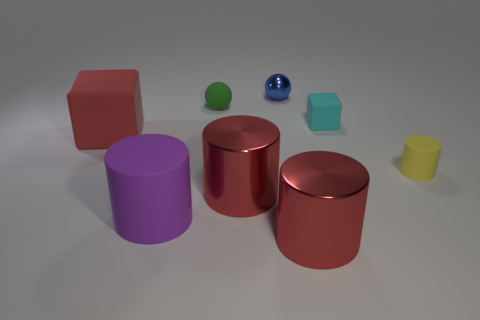How many red objects are either large rubber things or metal balls?
Keep it short and to the point. 1. Is there another matte object that has the same size as the green rubber thing?
Offer a very short reply. Yes. What material is the yellow cylinder that is the same size as the cyan matte thing?
Offer a terse response. Rubber. Is the size of the red object behind the yellow object the same as the cube on the right side of the tiny shiny sphere?
Provide a succinct answer. No. What number of things are either large red cylinders or blocks to the left of the small rubber block?
Give a very brief answer. 3. Is there a gray metal thing that has the same shape as the green thing?
Offer a very short reply. No. There is a rubber block behind the large red object behind the yellow thing; how big is it?
Give a very brief answer. Small. Is the large rubber cylinder the same color as the tiny cube?
Keep it short and to the point. No. What number of matte objects are green spheres or big blocks?
Provide a succinct answer. 2. How many red blocks are there?
Make the answer very short. 1. 